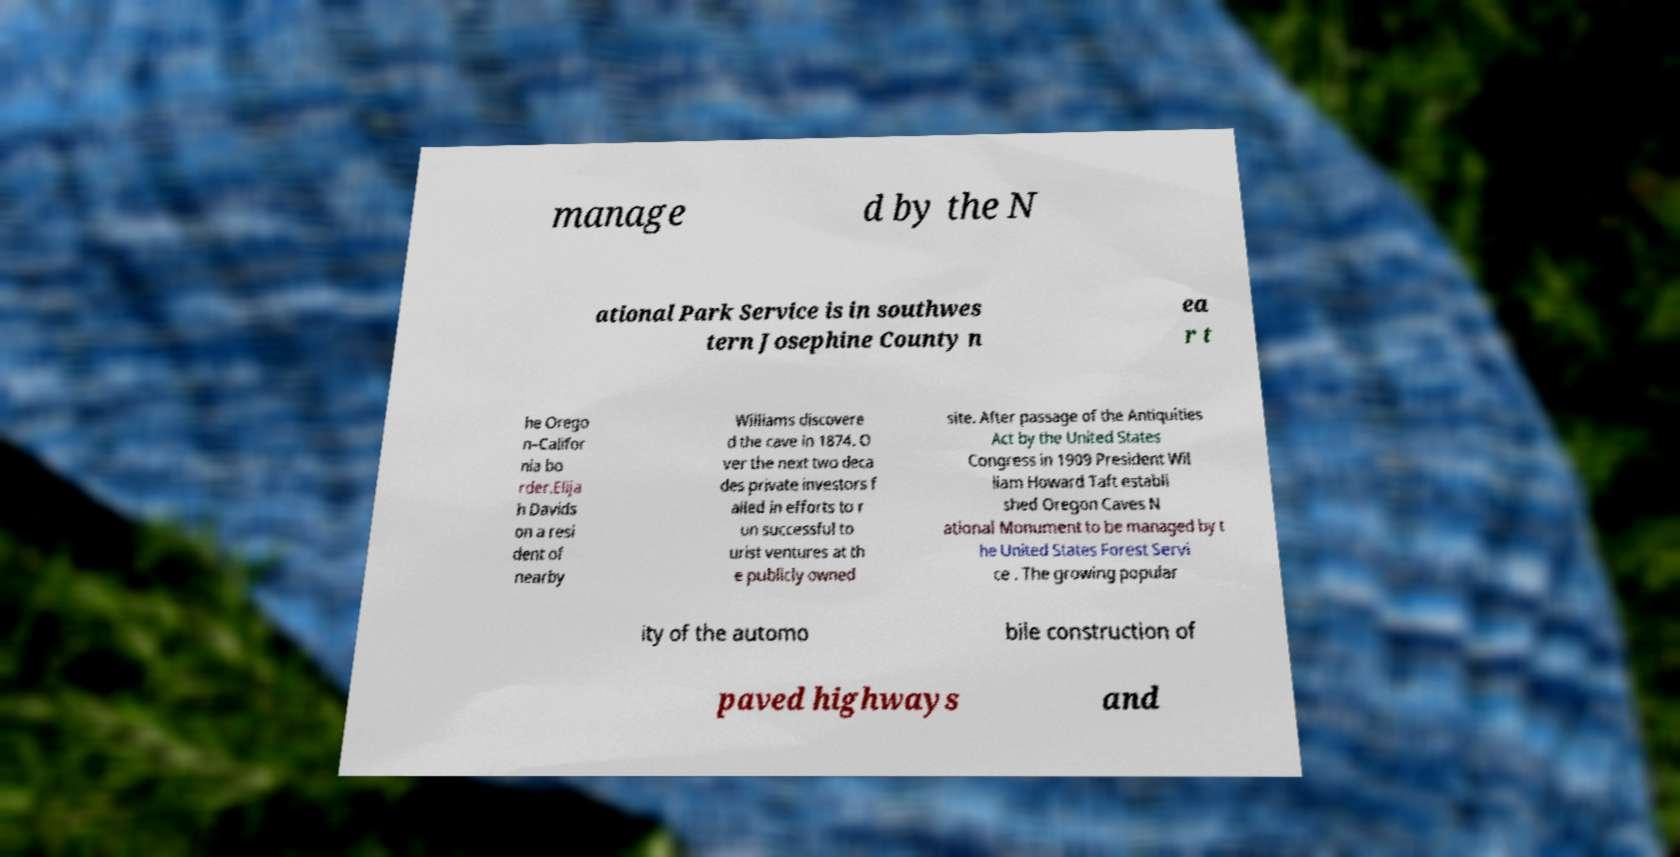What messages or text are displayed in this image? I need them in a readable, typed format. manage d by the N ational Park Service is in southwes tern Josephine County n ea r t he Orego n–Califor nia bo rder.Elija h Davids on a resi dent of nearby Williams discovere d the cave in 1874. O ver the next two deca des private investors f ailed in efforts to r un successful to urist ventures at th e publicly owned site. After passage of the Antiquities Act by the United States Congress in 1909 President Wil liam Howard Taft establi shed Oregon Caves N ational Monument to be managed by t he United States Forest Servi ce . The growing popular ity of the automo bile construction of paved highways and 